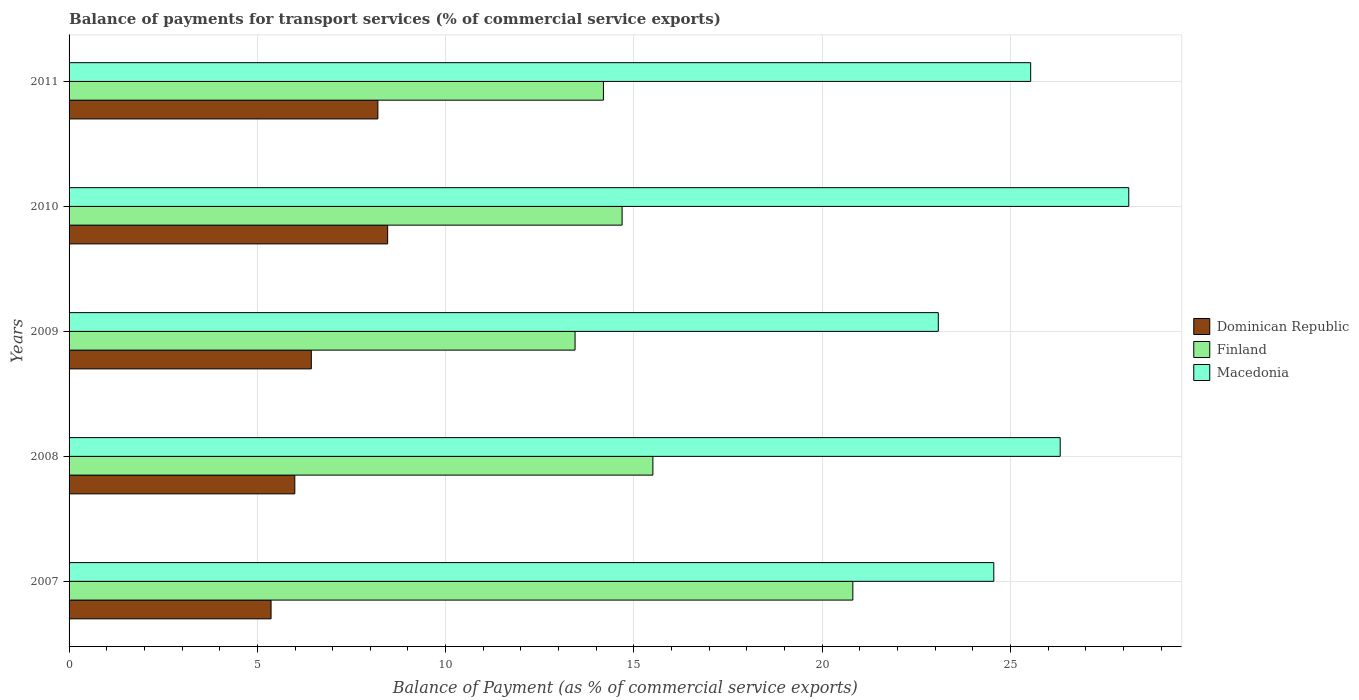How many different coloured bars are there?
Your answer should be very brief. 3. How many groups of bars are there?
Your answer should be compact. 5. Are the number of bars on each tick of the Y-axis equal?
Offer a terse response. Yes. How many bars are there on the 2nd tick from the top?
Provide a short and direct response. 3. How many bars are there on the 5th tick from the bottom?
Keep it short and to the point. 3. What is the label of the 4th group of bars from the top?
Your answer should be compact. 2008. In how many cases, is the number of bars for a given year not equal to the number of legend labels?
Provide a succinct answer. 0. What is the balance of payments for transport services in Dominican Republic in 2008?
Provide a short and direct response. 5.99. Across all years, what is the maximum balance of payments for transport services in Finland?
Your answer should be compact. 20.81. Across all years, what is the minimum balance of payments for transport services in Dominican Republic?
Offer a very short reply. 5.36. What is the total balance of payments for transport services in Dominican Republic in the graph?
Make the answer very short. 34.45. What is the difference between the balance of payments for transport services in Macedonia in 2008 and that in 2011?
Ensure brevity in your answer.  0.78. What is the difference between the balance of payments for transport services in Macedonia in 2011 and the balance of payments for transport services in Finland in 2008?
Make the answer very short. 10.03. What is the average balance of payments for transport services in Dominican Republic per year?
Offer a terse response. 6.89. In the year 2007, what is the difference between the balance of payments for transport services in Finland and balance of payments for transport services in Dominican Republic?
Your answer should be compact. 15.45. What is the ratio of the balance of payments for transport services in Dominican Republic in 2007 to that in 2008?
Offer a terse response. 0.89. Is the balance of payments for transport services in Finland in 2009 less than that in 2010?
Keep it short and to the point. Yes. What is the difference between the highest and the second highest balance of payments for transport services in Dominican Republic?
Keep it short and to the point. 0.26. What is the difference between the highest and the lowest balance of payments for transport services in Finland?
Your answer should be very brief. 7.38. What does the 1st bar from the top in 2008 represents?
Your response must be concise. Macedonia. What does the 3rd bar from the bottom in 2008 represents?
Give a very brief answer. Macedonia. Are the values on the major ticks of X-axis written in scientific E-notation?
Offer a terse response. No. Does the graph contain any zero values?
Offer a very short reply. No. Does the graph contain grids?
Your answer should be very brief. Yes. Where does the legend appear in the graph?
Offer a terse response. Center right. How many legend labels are there?
Ensure brevity in your answer.  3. What is the title of the graph?
Offer a very short reply. Balance of payments for transport services (% of commercial service exports). What is the label or title of the X-axis?
Offer a very short reply. Balance of Payment (as % of commercial service exports). What is the label or title of the Y-axis?
Give a very brief answer. Years. What is the Balance of Payment (as % of commercial service exports) of Dominican Republic in 2007?
Offer a terse response. 5.36. What is the Balance of Payment (as % of commercial service exports) of Finland in 2007?
Offer a terse response. 20.81. What is the Balance of Payment (as % of commercial service exports) in Macedonia in 2007?
Give a very brief answer. 24.56. What is the Balance of Payment (as % of commercial service exports) of Dominican Republic in 2008?
Offer a very short reply. 5.99. What is the Balance of Payment (as % of commercial service exports) in Finland in 2008?
Give a very brief answer. 15.5. What is the Balance of Payment (as % of commercial service exports) of Macedonia in 2008?
Keep it short and to the point. 26.32. What is the Balance of Payment (as % of commercial service exports) of Dominican Republic in 2009?
Keep it short and to the point. 6.43. What is the Balance of Payment (as % of commercial service exports) in Finland in 2009?
Offer a terse response. 13.44. What is the Balance of Payment (as % of commercial service exports) of Macedonia in 2009?
Offer a terse response. 23.08. What is the Balance of Payment (as % of commercial service exports) in Dominican Republic in 2010?
Keep it short and to the point. 8.46. What is the Balance of Payment (as % of commercial service exports) of Finland in 2010?
Your answer should be very brief. 14.69. What is the Balance of Payment (as % of commercial service exports) of Macedonia in 2010?
Offer a terse response. 28.14. What is the Balance of Payment (as % of commercial service exports) in Dominican Republic in 2011?
Make the answer very short. 8.2. What is the Balance of Payment (as % of commercial service exports) in Finland in 2011?
Your answer should be compact. 14.19. What is the Balance of Payment (as % of commercial service exports) in Macedonia in 2011?
Give a very brief answer. 25.54. Across all years, what is the maximum Balance of Payment (as % of commercial service exports) in Dominican Republic?
Keep it short and to the point. 8.46. Across all years, what is the maximum Balance of Payment (as % of commercial service exports) in Finland?
Keep it short and to the point. 20.81. Across all years, what is the maximum Balance of Payment (as % of commercial service exports) in Macedonia?
Offer a very short reply. 28.14. Across all years, what is the minimum Balance of Payment (as % of commercial service exports) in Dominican Republic?
Provide a succinct answer. 5.36. Across all years, what is the minimum Balance of Payment (as % of commercial service exports) in Finland?
Provide a short and direct response. 13.44. Across all years, what is the minimum Balance of Payment (as % of commercial service exports) of Macedonia?
Your response must be concise. 23.08. What is the total Balance of Payment (as % of commercial service exports) in Dominican Republic in the graph?
Provide a short and direct response. 34.45. What is the total Balance of Payment (as % of commercial service exports) in Finland in the graph?
Keep it short and to the point. 78.63. What is the total Balance of Payment (as % of commercial service exports) in Macedonia in the graph?
Offer a very short reply. 127.64. What is the difference between the Balance of Payment (as % of commercial service exports) in Dominican Republic in 2007 and that in 2008?
Offer a terse response. -0.63. What is the difference between the Balance of Payment (as % of commercial service exports) in Finland in 2007 and that in 2008?
Your answer should be very brief. 5.31. What is the difference between the Balance of Payment (as % of commercial service exports) in Macedonia in 2007 and that in 2008?
Make the answer very short. -1.76. What is the difference between the Balance of Payment (as % of commercial service exports) in Dominican Republic in 2007 and that in 2009?
Your response must be concise. -1.07. What is the difference between the Balance of Payment (as % of commercial service exports) of Finland in 2007 and that in 2009?
Give a very brief answer. 7.38. What is the difference between the Balance of Payment (as % of commercial service exports) of Macedonia in 2007 and that in 2009?
Provide a succinct answer. 1.47. What is the difference between the Balance of Payment (as % of commercial service exports) of Dominican Republic in 2007 and that in 2010?
Offer a very short reply. -3.1. What is the difference between the Balance of Payment (as % of commercial service exports) in Finland in 2007 and that in 2010?
Offer a terse response. 6.13. What is the difference between the Balance of Payment (as % of commercial service exports) of Macedonia in 2007 and that in 2010?
Your answer should be compact. -3.58. What is the difference between the Balance of Payment (as % of commercial service exports) of Dominican Republic in 2007 and that in 2011?
Make the answer very short. -2.84. What is the difference between the Balance of Payment (as % of commercial service exports) of Finland in 2007 and that in 2011?
Provide a short and direct response. 6.62. What is the difference between the Balance of Payment (as % of commercial service exports) in Macedonia in 2007 and that in 2011?
Your response must be concise. -0.98. What is the difference between the Balance of Payment (as % of commercial service exports) of Dominican Republic in 2008 and that in 2009?
Offer a very short reply. -0.44. What is the difference between the Balance of Payment (as % of commercial service exports) in Finland in 2008 and that in 2009?
Give a very brief answer. 2.07. What is the difference between the Balance of Payment (as % of commercial service exports) in Macedonia in 2008 and that in 2009?
Your response must be concise. 3.24. What is the difference between the Balance of Payment (as % of commercial service exports) of Dominican Republic in 2008 and that in 2010?
Make the answer very short. -2.47. What is the difference between the Balance of Payment (as % of commercial service exports) in Finland in 2008 and that in 2010?
Offer a terse response. 0.82. What is the difference between the Balance of Payment (as % of commercial service exports) in Macedonia in 2008 and that in 2010?
Give a very brief answer. -1.82. What is the difference between the Balance of Payment (as % of commercial service exports) in Dominican Republic in 2008 and that in 2011?
Provide a succinct answer. -2.21. What is the difference between the Balance of Payment (as % of commercial service exports) in Finland in 2008 and that in 2011?
Offer a very short reply. 1.31. What is the difference between the Balance of Payment (as % of commercial service exports) in Macedonia in 2008 and that in 2011?
Ensure brevity in your answer.  0.78. What is the difference between the Balance of Payment (as % of commercial service exports) in Dominican Republic in 2009 and that in 2010?
Your answer should be compact. -2.03. What is the difference between the Balance of Payment (as % of commercial service exports) of Finland in 2009 and that in 2010?
Keep it short and to the point. -1.25. What is the difference between the Balance of Payment (as % of commercial service exports) in Macedonia in 2009 and that in 2010?
Keep it short and to the point. -5.06. What is the difference between the Balance of Payment (as % of commercial service exports) of Dominican Republic in 2009 and that in 2011?
Your answer should be very brief. -1.77. What is the difference between the Balance of Payment (as % of commercial service exports) of Finland in 2009 and that in 2011?
Keep it short and to the point. -0.75. What is the difference between the Balance of Payment (as % of commercial service exports) of Macedonia in 2009 and that in 2011?
Your answer should be compact. -2.45. What is the difference between the Balance of Payment (as % of commercial service exports) in Dominican Republic in 2010 and that in 2011?
Make the answer very short. 0.26. What is the difference between the Balance of Payment (as % of commercial service exports) in Finland in 2010 and that in 2011?
Your answer should be very brief. 0.5. What is the difference between the Balance of Payment (as % of commercial service exports) of Macedonia in 2010 and that in 2011?
Offer a terse response. 2.6. What is the difference between the Balance of Payment (as % of commercial service exports) in Dominican Republic in 2007 and the Balance of Payment (as % of commercial service exports) in Finland in 2008?
Offer a very short reply. -10.14. What is the difference between the Balance of Payment (as % of commercial service exports) in Dominican Republic in 2007 and the Balance of Payment (as % of commercial service exports) in Macedonia in 2008?
Your response must be concise. -20.96. What is the difference between the Balance of Payment (as % of commercial service exports) of Finland in 2007 and the Balance of Payment (as % of commercial service exports) of Macedonia in 2008?
Your answer should be very brief. -5.51. What is the difference between the Balance of Payment (as % of commercial service exports) of Dominican Republic in 2007 and the Balance of Payment (as % of commercial service exports) of Finland in 2009?
Provide a short and direct response. -8.07. What is the difference between the Balance of Payment (as % of commercial service exports) in Dominican Republic in 2007 and the Balance of Payment (as % of commercial service exports) in Macedonia in 2009?
Offer a very short reply. -17.72. What is the difference between the Balance of Payment (as % of commercial service exports) of Finland in 2007 and the Balance of Payment (as % of commercial service exports) of Macedonia in 2009?
Provide a short and direct response. -2.27. What is the difference between the Balance of Payment (as % of commercial service exports) in Dominican Republic in 2007 and the Balance of Payment (as % of commercial service exports) in Finland in 2010?
Your answer should be compact. -9.32. What is the difference between the Balance of Payment (as % of commercial service exports) of Dominican Republic in 2007 and the Balance of Payment (as % of commercial service exports) of Macedonia in 2010?
Provide a succinct answer. -22.78. What is the difference between the Balance of Payment (as % of commercial service exports) of Finland in 2007 and the Balance of Payment (as % of commercial service exports) of Macedonia in 2010?
Provide a short and direct response. -7.33. What is the difference between the Balance of Payment (as % of commercial service exports) of Dominican Republic in 2007 and the Balance of Payment (as % of commercial service exports) of Finland in 2011?
Offer a very short reply. -8.83. What is the difference between the Balance of Payment (as % of commercial service exports) of Dominican Republic in 2007 and the Balance of Payment (as % of commercial service exports) of Macedonia in 2011?
Provide a succinct answer. -20.17. What is the difference between the Balance of Payment (as % of commercial service exports) in Finland in 2007 and the Balance of Payment (as % of commercial service exports) in Macedonia in 2011?
Your answer should be compact. -4.72. What is the difference between the Balance of Payment (as % of commercial service exports) of Dominican Republic in 2008 and the Balance of Payment (as % of commercial service exports) of Finland in 2009?
Offer a very short reply. -7.44. What is the difference between the Balance of Payment (as % of commercial service exports) in Dominican Republic in 2008 and the Balance of Payment (as % of commercial service exports) in Macedonia in 2009?
Make the answer very short. -17.09. What is the difference between the Balance of Payment (as % of commercial service exports) in Finland in 2008 and the Balance of Payment (as % of commercial service exports) in Macedonia in 2009?
Provide a short and direct response. -7.58. What is the difference between the Balance of Payment (as % of commercial service exports) in Dominican Republic in 2008 and the Balance of Payment (as % of commercial service exports) in Finland in 2010?
Your answer should be compact. -8.69. What is the difference between the Balance of Payment (as % of commercial service exports) of Dominican Republic in 2008 and the Balance of Payment (as % of commercial service exports) of Macedonia in 2010?
Offer a terse response. -22.15. What is the difference between the Balance of Payment (as % of commercial service exports) of Finland in 2008 and the Balance of Payment (as % of commercial service exports) of Macedonia in 2010?
Your answer should be compact. -12.64. What is the difference between the Balance of Payment (as % of commercial service exports) of Dominican Republic in 2008 and the Balance of Payment (as % of commercial service exports) of Finland in 2011?
Your response must be concise. -8.2. What is the difference between the Balance of Payment (as % of commercial service exports) in Dominican Republic in 2008 and the Balance of Payment (as % of commercial service exports) in Macedonia in 2011?
Keep it short and to the point. -19.54. What is the difference between the Balance of Payment (as % of commercial service exports) of Finland in 2008 and the Balance of Payment (as % of commercial service exports) of Macedonia in 2011?
Ensure brevity in your answer.  -10.03. What is the difference between the Balance of Payment (as % of commercial service exports) in Dominican Republic in 2009 and the Balance of Payment (as % of commercial service exports) in Finland in 2010?
Ensure brevity in your answer.  -8.25. What is the difference between the Balance of Payment (as % of commercial service exports) in Dominican Republic in 2009 and the Balance of Payment (as % of commercial service exports) in Macedonia in 2010?
Give a very brief answer. -21.71. What is the difference between the Balance of Payment (as % of commercial service exports) of Finland in 2009 and the Balance of Payment (as % of commercial service exports) of Macedonia in 2010?
Your answer should be compact. -14.7. What is the difference between the Balance of Payment (as % of commercial service exports) of Dominican Republic in 2009 and the Balance of Payment (as % of commercial service exports) of Finland in 2011?
Offer a terse response. -7.76. What is the difference between the Balance of Payment (as % of commercial service exports) in Dominican Republic in 2009 and the Balance of Payment (as % of commercial service exports) in Macedonia in 2011?
Offer a terse response. -19.1. What is the difference between the Balance of Payment (as % of commercial service exports) in Finland in 2009 and the Balance of Payment (as % of commercial service exports) in Macedonia in 2011?
Your answer should be very brief. -12.1. What is the difference between the Balance of Payment (as % of commercial service exports) of Dominican Republic in 2010 and the Balance of Payment (as % of commercial service exports) of Finland in 2011?
Your response must be concise. -5.73. What is the difference between the Balance of Payment (as % of commercial service exports) in Dominican Republic in 2010 and the Balance of Payment (as % of commercial service exports) in Macedonia in 2011?
Make the answer very short. -17.08. What is the difference between the Balance of Payment (as % of commercial service exports) in Finland in 2010 and the Balance of Payment (as % of commercial service exports) in Macedonia in 2011?
Your answer should be compact. -10.85. What is the average Balance of Payment (as % of commercial service exports) in Dominican Republic per year?
Give a very brief answer. 6.89. What is the average Balance of Payment (as % of commercial service exports) in Finland per year?
Offer a terse response. 15.73. What is the average Balance of Payment (as % of commercial service exports) in Macedonia per year?
Provide a short and direct response. 25.53. In the year 2007, what is the difference between the Balance of Payment (as % of commercial service exports) in Dominican Republic and Balance of Payment (as % of commercial service exports) in Finland?
Offer a very short reply. -15.45. In the year 2007, what is the difference between the Balance of Payment (as % of commercial service exports) of Dominican Republic and Balance of Payment (as % of commercial service exports) of Macedonia?
Provide a short and direct response. -19.19. In the year 2007, what is the difference between the Balance of Payment (as % of commercial service exports) of Finland and Balance of Payment (as % of commercial service exports) of Macedonia?
Your response must be concise. -3.74. In the year 2008, what is the difference between the Balance of Payment (as % of commercial service exports) in Dominican Republic and Balance of Payment (as % of commercial service exports) in Finland?
Offer a terse response. -9.51. In the year 2008, what is the difference between the Balance of Payment (as % of commercial service exports) in Dominican Republic and Balance of Payment (as % of commercial service exports) in Macedonia?
Provide a short and direct response. -20.33. In the year 2008, what is the difference between the Balance of Payment (as % of commercial service exports) of Finland and Balance of Payment (as % of commercial service exports) of Macedonia?
Give a very brief answer. -10.82. In the year 2009, what is the difference between the Balance of Payment (as % of commercial service exports) of Dominican Republic and Balance of Payment (as % of commercial service exports) of Finland?
Your answer should be very brief. -7. In the year 2009, what is the difference between the Balance of Payment (as % of commercial service exports) in Dominican Republic and Balance of Payment (as % of commercial service exports) in Macedonia?
Your response must be concise. -16.65. In the year 2009, what is the difference between the Balance of Payment (as % of commercial service exports) of Finland and Balance of Payment (as % of commercial service exports) of Macedonia?
Give a very brief answer. -9.65. In the year 2010, what is the difference between the Balance of Payment (as % of commercial service exports) in Dominican Republic and Balance of Payment (as % of commercial service exports) in Finland?
Make the answer very short. -6.23. In the year 2010, what is the difference between the Balance of Payment (as % of commercial service exports) of Dominican Republic and Balance of Payment (as % of commercial service exports) of Macedonia?
Your response must be concise. -19.68. In the year 2010, what is the difference between the Balance of Payment (as % of commercial service exports) of Finland and Balance of Payment (as % of commercial service exports) of Macedonia?
Offer a terse response. -13.45. In the year 2011, what is the difference between the Balance of Payment (as % of commercial service exports) in Dominican Republic and Balance of Payment (as % of commercial service exports) in Finland?
Give a very brief answer. -5.99. In the year 2011, what is the difference between the Balance of Payment (as % of commercial service exports) in Dominican Republic and Balance of Payment (as % of commercial service exports) in Macedonia?
Provide a succinct answer. -17.34. In the year 2011, what is the difference between the Balance of Payment (as % of commercial service exports) of Finland and Balance of Payment (as % of commercial service exports) of Macedonia?
Make the answer very short. -11.35. What is the ratio of the Balance of Payment (as % of commercial service exports) of Dominican Republic in 2007 to that in 2008?
Provide a succinct answer. 0.89. What is the ratio of the Balance of Payment (as % of commercial service exports) of Finland in 2007 to that in 2008?
Your answer should be very brief. 1.34. What is the ratio of the Balance of Payment (as % of commercial service exports) of Macedonia in 2007 to that in 2008?
Keep it short and to the point. 0.93. What is the ratio of the Balance of Payment (as % of commercial service exports) of Dominican Republic in 2007 to that in 2009?
Give a very brief answer. 0.83. What is the ratio of the Balance of Payment (as % of commercial service exports) of Finland in 2007 to that in 2009?
Your response must be concise. 1.55. What is the ratio of the Balance of Payment (as % of commercial service exports) in Macedonia in 2007 to that in 2009?
Your answer should be compact. 1.06. What is the ratio of the Balance of Payment (as % of commercial service exports) in Dominican Republic in 2007 to that in 2010?
Make the answer very short. 0.63. What is the ratio of the Balance of Payment (as % of commercial service exports) in Finland in 2007 to that in 2010?
Your answer should be compact. 1.42. What is the ratio of the Balance of Payment (as % of commercial service exports) of Macedonia in 2007 to that in 2010?
Provide a succinct answer. 0.87. What is the ratio of the Balance of Payment (as % of commercial service exports) in Dominican Republic in 2007 to that in 2011?
Ensure brevity in your answer.  0.65. What is the ratio of the Balance of Payment (as % of commercial service exports) in Finland in 2007 to that in 2011?
Make the answer very short. 1.47. What is the ratio of the Balance of Payment (as % of commercial service exports) of Macedonia in 2007 to that in 2011?
Keep it short and to the point. 0.96. What is the ratio of the Balance of Payment (as % of commercial service exports) of Dominican Republic in 2008 to that in 2009?
Provide a succinct answer. 0.93. What is the ratio of the Balance of Payment (as % of commercial service exports) of Finland in 2008 to that in 2009?
Provide a short and direct response. 1.15. What is the ratio of the Balance of Payment (as % of commercial service exports) of Macedonia in 2008 to that in 2009?
Make the answer very short. 1.14. What is the ratio of the Balance of Payment (as % of commercial service exports) of Dominican Republic in 2008 to that in 2010?
Make the answer very short. 0.71. What is the ratio of the Balance of Payment (as % of commercial service exports) in Finland in 2008 to that in 2010?
Your answer should be very brief. 1.06. What is the ratio of the Balance of Payment (as % of commercial service exports) in Macedonia in 2008 to that in 2010?
Your answer should be very brief. 0.94. What is the ratio of the Balance of Payment (as % of commercial service exports) in Dominican Republic in 2008 to that in 2011?
Your response must be concise. 0.73. What is the ratio of the Balance of Payment (as % of commercial service exports) of Finland in 2008 to that in 2011?
Offer a very short reply. 1.09. What is the ratio of the Balance of Payment (as % of commercial service exports) of Macedonia in 2008 to that in 2011?
Ensure brevity in your answer.  1.03. What is the ratio of the Balance of Payment (as % of commercial service exports) of Dominican Republic in 2009 to that in 2010?
Make the answer very short. 0.76. What is the ratio of the Balance of Payment (as % of commercial service exports) in Finland in 2009 to that in 2010?
Keep it short and to the point. 0.91. What is the ratio of the Balance of Payment (as % of commercial service exports) of Macedonia in 2009 to that in 2010?
Your answer should be compact. 0.82. What is the ratio of the Balance of Payment (as % of commercial service exports) of Dominican Republic in 2009 to that in 2011?
Provide a succinct answer. 0.78. What is the ratio of the Balance of Payment (as % of commercial service exports) of Finland in 2009 to that in 2011?
Keep it short and to the point. 0.95. What is the ratio of the Balance of Payment (as % of commercial service exports) in Macedonia in 2009 to that in 2011?
Your answer should be compact. 0.9. What is the ratio of the Balance of Payment (as % of commercial service exports) of Dominican Republic in 2010 to that in 2011?
Offer a very short reply. 1.03. What is the ratio of the Balance of Payment (as % of commercial service exports) in Finland in 2010 to that in 2011?
Make the answer very short. 1.03. What is the ratio of the Balance of Payment (as % of commercial service exports) of Macedonia in 2010 to that in 2011?
Provide a short and direct response. 1.1. What is the difference between the highest and the second highest Balance of Payment (as % of commercial service exports) in Dominican Republic?
Provide a succinct answer. 0.26. What is the difference between the highest and the second highest Balance of Payment (as % of commercial service exports) of Finland?
Your response must be concise. 5.31. What is the difference between the highest and the second highest Balance of Payment (as % of commercial service exports) in Macedonia?
Provide a short and direct response. 1.82. What is the difference between the highest and the lowest Balance of Payment (as % of commercial service exports) of Dominican Republic?
Provide a short and direct response. 3.1. What is the difference between the highest and the lowest Balance of Payment (as % of commercial service exports) of Finland?
Your answer should be very brief. 7.38. What is the difference between the highest and the lowest Balance of Payment (as % of commercial service exports) in Macedonia?
Offer a very short reply. 5.06. 